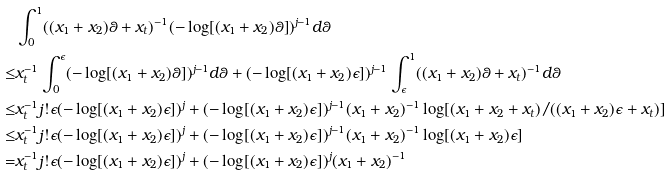<formula> <loc_0><loc_0><loc_500><loc_500>& \int _ { 0 } ^ { 1 } ( ( x _ { 1 } + x _ { 2 } ) \theta + x _ { t } ) ^ { - 1 } ( - \log [ ( x _ { 1 } + x _ { 2 } ) \theta ] ) ^ { j - 1 } d \theta \\ \leq & x _ { t } ^ { - 1 } \int _ { 0 } ^ { \epsilon } ( - \log [ ( x _ { 1 } + x _ { 2 } ) \theta ] ) ^ { j - 1 } d \theta + ( - \log [ ( x _ { 1 } + x _ { 2 } ) \epsilon ] ) ^ { j - 1 } \int _ { \epsilon } ^ { 1 } ( ( x _ { 1 } + x _ { 2 } ) \theta + x _ { t } ) ^ { - 1 } d \theta \\ \leq & x _ { t } ^ { - 1 } j ! \epsilon ( - \log [ ( x _ { 1 } + x _ { 2 } ) \epsilon ] ) ^ { j } + ( - \log [ ( x _ { 1 } + x _ { 2 } ) \epsilon ] ) ^ { j - 1 } ( x _ { 1 } + x _ { 2 } ) ^ { - 1 } \log [ ( x _ { 1 } + x _ { 2 } + x _ { t } ) / ( ( x _ { 1 } + x _ { 2 } ) \epsilon + x _ { t } ) ] \\ \leq & x _ { t } ^ { - 1 } j ! \epsilon ( - \log [ ( x _ { 1 } + x _ { 2 } ) \epsilon ] ) ^ { j } + ( - \log [ ( x _ { 1 } + x _ { 2 } ) \epsilon ] ) ^ { j - 1 } ( x _ { 1 } + x _ { 2 } ) ^ { - 1 } \log [ ( x _ { 1 } + x _ { 2 } ) \epsilon ] \\ = & x _ { t } ^ { - 1 } j ! \epsilon ( - \log [ ( x _ { 1 } + x _ { 2 } ) \epsilon ] ) ^ { j } + ( - \log [ ( x _ { 1 } + x _ { 2 } ) \epsilon ] ) ^ { j } ( x _ { 1 } + x _ { 2 } ) ^ { - 1 }</formula> 